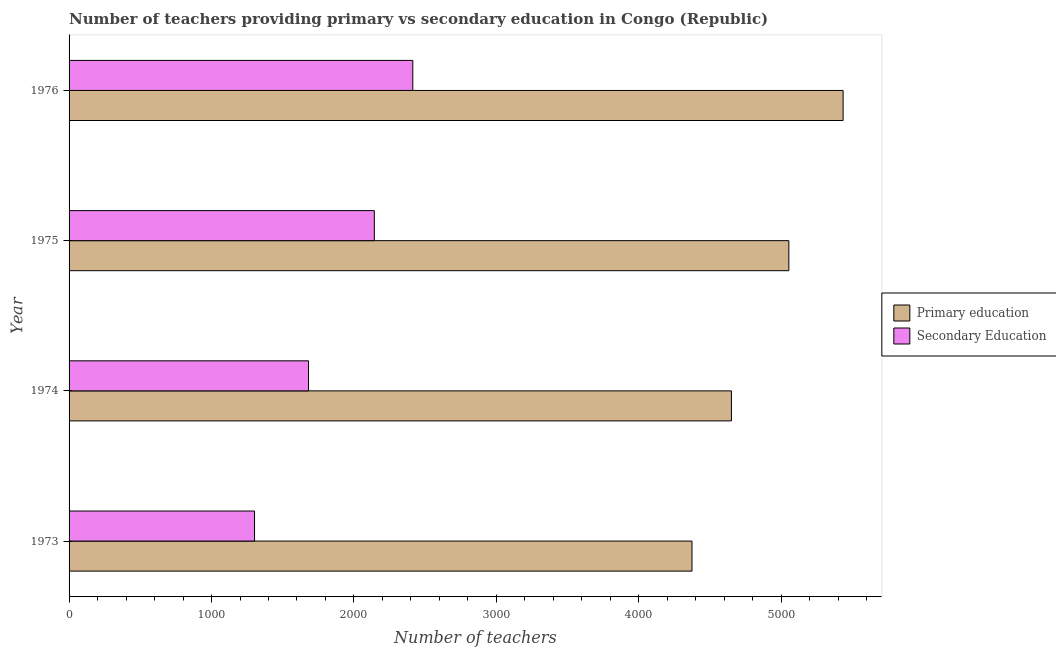How many groups of bars are there?
Your answer should be compact. 4. Are the number of bars per tick equal to the number of legend labels?
Offer a very short reply. Yes. Are the number of bars on each tick of the Y-axis equal?
Your answer should be very brief. Yes. What is the label of the 2nd group of bars from the top?
Provide a short and direct response. 1975. What is the number of primary teachers in 1974?
Provide a short and direct response. 4650. Across all years, what is the maximum number of secondary teachers?
Provide a succinct answer. 2413. Across all years, what is the minimum number of secondary teachers?
Give a very brief answer. 1302. In which year was the number of primary teachers maximum?
Ensure brevity in your answer.  1976. In which year was the number of primary teachers minimum?
Provide a succinct answer. 1973. What is the total number of secondary teachers in the graph?
Offer a very short reply. 7539. What is the difference between the number of primary teachers in 1975 and that in 1976?
Your answer should be very brief. -381. What is the difference between the number of primary teachers in 1975 and the number of secondary teachers in 1974?
Your response must be concise. 3372. What is the average number of secondary teachers per year?
Your answer should be compact. 1884.75. In the year 1974, what is the difference between the number of primary teachers and number of secondary teachers?
Give a very brief answer. 2969. In how many years, is the number of secondary teachers greater than 1400 ?
Give a very brief answer. 3. What is the ratio of the number of primary teachers in 1973 to that in 1974?
Make the answer very short. 0.94. What is the difference between the highest and the second highest number of primary teachers?
Offer a very short reply. 381. What is the difference between the highest and the lowest number of primary teachers?
Your answer should be compact. 1061. In how many years, is the number of primary teachers greater than the average number of primary teachers taken over all years?
Provide a short and direct response. 2. Is the sum of the number of secondary teachers in 1973 and 1974 greater than the maximum number of primary teachers across all years?
Give a very brief answer. No. What does the 1st bar from the top in 1976 represents?
Ensure brevity in your answer.  Secondary Education. Are all the bars in the graph horizontal?
Your response must be concise. Yes. How many years are there in the graph?
Give a very brief answer. 4. What is the difference between two consecutive major ticks on the X-axis?
Ensure brevity in your answer.  1000. Are the values on the major ticks of X-axis written in scientific E-notation?
Your answer should be compact. No. Does the graph contain any zero values?
Offer a terse response. No. Does the graph contain grids?
Your answer should be compact. No. Where does the legend appear in the graph?
Make the answer very short. Center right. How many legend labels are there?
Your answer should be very brief. 2. How are the legend labels stacked?
Keep it short and to the point. Vertical. What is the title of the graph?
Ensure brevity in your answer.  Number of teachers providing primary vs secondary education in Congo (Republic). What is the label or title of the X-axis?
Give a very brief answer. Number of teachers. What is the Number of teachers in Primary education in 1973?
Your answer should be compact. 4373. What is the Number of teachers in Secondary Education in 1973?
Offer a terse response. 1302. What is the Number of teachers in Primary education in 1974?
Provide a short and direct response. 4650. What is the Number of teachers in Secondary Education in 1974?
Ensure brevity in your answer.  1681. What is the Number of teachers of Primary education in 1975?
Provide a succinct answer. 5053. What is the Number of teachers in Secondary Education in 1975?
Make the answer very short. 2143. What is the Number of teachers in Primary education in 1976?
Offer a very short reply. 5434. What is the Number of teachers in Secondary Education in 1976?
Ensure brevity in your answer.  2413. Across all years, what is the maximum Number of teachers of Primary education?
Ensure brevity in your answer.  5434. Across all years, what is the maximum Number of teachers in Secondary Education?
Offer a very short reply. 2413. Across all years, what is the minimum Number of teachers of Primary education?
Keep it short and to the point. 4373. Across all years, what is the minimum Number of teachers of Secondary Education?
Offer a terse response. 1302. What is the total Number of teachers in Primary education in the graph?
Provide a succinct answer. 1.95e+04. What is the total Number of teachers in Secondary Education in the graph?
Offer a terse response. 7539. What is the difference between the Number of teachers of Primary education in 1973 and that in 1974?
Give a very brief answer. -277. What is the difference between the Number of teachers of Secondary Education in 1973 and that in 1974?
Provide a succinct answer. -379. What is the difference between the Number of teachers in Primary education in 1973 and that in 1975?
Offer a terse response. -680. What is the difference between the Number of teachers in Secondary Education in 1973 and that in 1975?
Provide a succinct answer. -841. What is the difference between the Number of teachers of Primary education in 1973 and that in 1976?
Make the answer very short. -1061. What is the difference between the Number of teachers of Secondary Education in 1973 and that in 1976?
Your answer should be compact. -1111. What is the difference between the Number of teachers in Primary education in 1974 and that in 1975?
Offer a terse response. -403. What is the difference between the Number of teachers in Secondary Education in 1974 and that in 1975?
Provide a short and direct response. -462. What is the difference between the Number of teachers of Primary education in 1974 and that in 1976?
Make the answer very short. -784. What is the difference between the Number of teachers in Secondary Education in 1974 and that in 1976?
Make the answer very short. -732. What is the difference between the Number of teachers in Primary education in 1975 and that in 1976?
Your answer should be compact. -381. What is the difference between the Number of teachers of Secondary Education in 1975 and that in 1976?
Provide a succinct answer. -270. What is the difference between the Number of teachers of Primary education in 1973 and the Number of teachers of Secondary Education in 1974?
Ensure brevity in your answer.  2692. What is the difference between the Number of teachers of Primary education in 1973 and the Number of teachers of Secondary Education in 1975?
Provide a short and direct response. 2230. What is the difference between the Number of teachers of Primary education in 1973 and the Number of teachers of Secondary Education in 1976?
Keep it short and to the point. 1960. What is the difference between the Number of teachers of Primary education in 1974 and the Number of teachers of Secondary Education in 1975?
Provide a short and direct response. 2507. What is the difference between the Number of teachers in Primary education in 1974 and the Number of teachers in Secondary Education in 1976?
Your response must be concise. 2237. What is the difference between the Number of teachers in Primary education in 1975 and the Number of teachers in Secondary Education in 1976?
Your answer should be compact. 2640. What is the average Number of teachers of Primary education per year?
Ensure brevity in your answer.  4877.5. What is the average Number of teachers in Secondary Education per year?
Ensure brevity in your answer.  1884.75. In the year 1973, what is the difference between the Number of teachers in Primary education and Number of teachers in Secondary Education?
Offer a very short reply. 3071. In the year 1974, what is the difference between the Number of teachers in Primary education and Number of teachers in Secondary Education?
Ensure brevity in your answer.  2969. In the year 1975, what is the difference between the Number of teachers of Primary education and Number of teachers of Secondary Education?
Your answer should be very brief. 2910. In the year 1976, what is the difference between the Number of teachers in Primary education and Number of teachers in Secondary Education?
Offer a very short reply. 3021. What is the ratio of the Number of teachers of Primary education in 1973 to that in 1974?
Keep it short and to the point. 0.94. What is the ratio of the Number of teachers in Secondary Education in 1973 to that in 1974?
Make the answer very short. 0.77. What is the ratio of the Number of teachers of Primary education in 1973 to that in 1975?
Provide a short and direct response. 0.87. What is the ratio of the Number of teachers in Secondary Education in 1973 to that in 1975?
Offer a terse response. 0.61. What is the ratio of the Number of teachers in Primary education in 1973 to that in 1976?
Ensure brevity in your answer.  0.8. What is the ratio of the Number of teachers of Secondary Education in 1973 to that in 1976?
Your response must be concise. 0.54. What is the ratio of the Number of teachers in Primary education in 1974 to that in 1975?
Your response must be concise. 0.92. What is the ratio of the Number of teachers of Secondary Education in 1974 to that in 1975?
Keep it short and to the point. 0.78. What is the ratio of the Number of teachers of Primary education in 1974 to that in 1976?
Offer a very short reply. 0.86. What is the ratio of the Number of teachers of Secondary Education in 1974 to that in 1976?
Ensure brevity in your answer.  0.7. What is the ratio of the Number of teachers of Primary education in 1975 to that in 1976?
Your answer should be very brief. 0.93. What is the ratio of the Number of teachers of Secondary Education in 1975 to that in 1976?
Provide a succinct answer. 0.89. What is the difference between the highest and the second highest Number of teachers of Primary education?
Your answer should be very brief. 381. What is the difference between the highest and the second highest Number of teachers in Secondary Education?
Ensure brevity in your answer.  270. What is the difference between the highest and the lowest Number of teachers in Primary education?
Provide a succinct answer. 1061. What is the difference between the highest and the lowest Number of teachers in Secondary Education?
Offer a very short reply. 1111. 